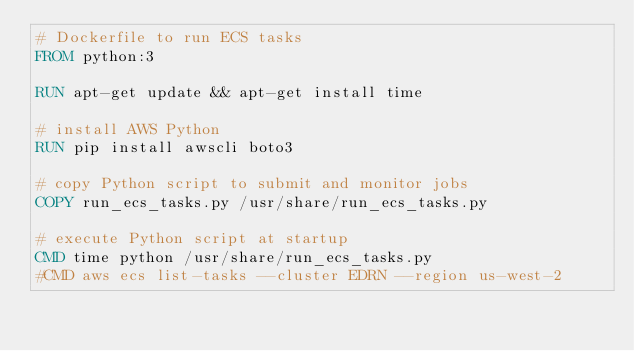<code> <loc_0><loc_0><loc_500><loc_500><_Dockerfile_># Dockerfile to run ECS tasks
FROM python:3

RUN apt-get update && apt-get install time

# install AWS Python
RUN pip install awscli boto3

# copy Python script to submit and monitor jobs
COPY run_ecs_tasks.py /usr/share/run_ecs_tasks.py

# execute Python script at startup
CMD time python /usr/share/run_ecs_tasks.py
#CMD aws ecs list-tasks --cluster EDRN --region us-west-2
</code> 